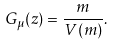Convert formula to latex. <formula><loc_0><loc_0><loc_500><loc_500>G _ { \mu } ( z ) = \frac { m } { V ( m ) } .</formula> 